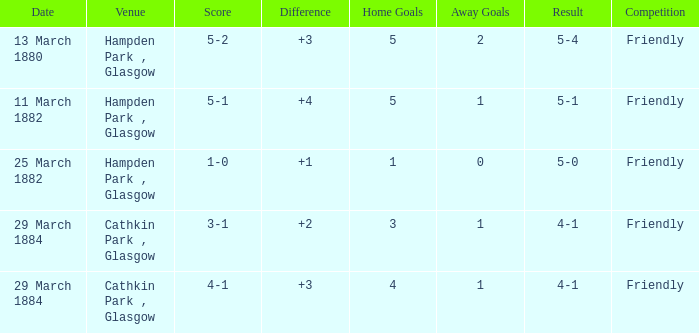Write the full table. {'header': ['Date', 'Venue', 'Score', 'Difference', 'Home Goals', 'Away Goals', 'Result', 'Competition'], 'rows': [['13 March 1880', 'Hampden Park , Glasgow', '5-2', '+3', '5', '2', '5-4', 'Friendly'], ['11 March 1882', 'Hampden Park , Glasgow', '5-1', '+4', '5', '1', '5-1', 'Friendly'], ['25 March 1882', 'Hampden Park , Glasgow', '1-0', '+1', '1', '0', '5-0', 'Friendly'], ['29 March 1884', 'Cathkin Park , Glasgow', '3-1', '+2', '3', '1', '4-1', 'Friendly'], ['29 March 1884', 'Cathkin Park , Glasgow', '4-1', '+3', '4', '1', '4-1', 'Friendly']]} Which item has a score of 5-1? 5-1. 